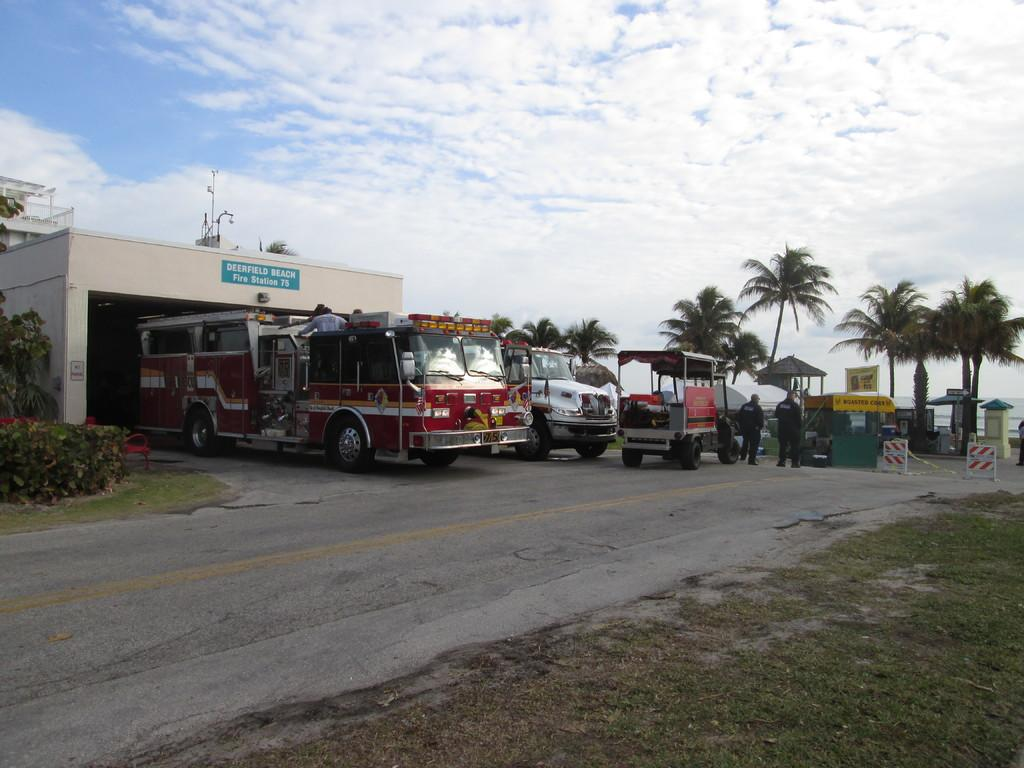What can be seen on the road in the image? There are vehicles on the road in the image. What structure is located on the right side of the image? There is a building on the right side of the image. What type of natural vegetation is visible in the image? There are trees visible in the image. What is visible at the top of the image? The sky is visible at the top of the image. What can be observed in the sky? Clouds are present in the sky. Can you see a face on the building in the image? There is no face visible on the building in the image. Is there a basketball court in the image? There is no basketball court present in the image. 